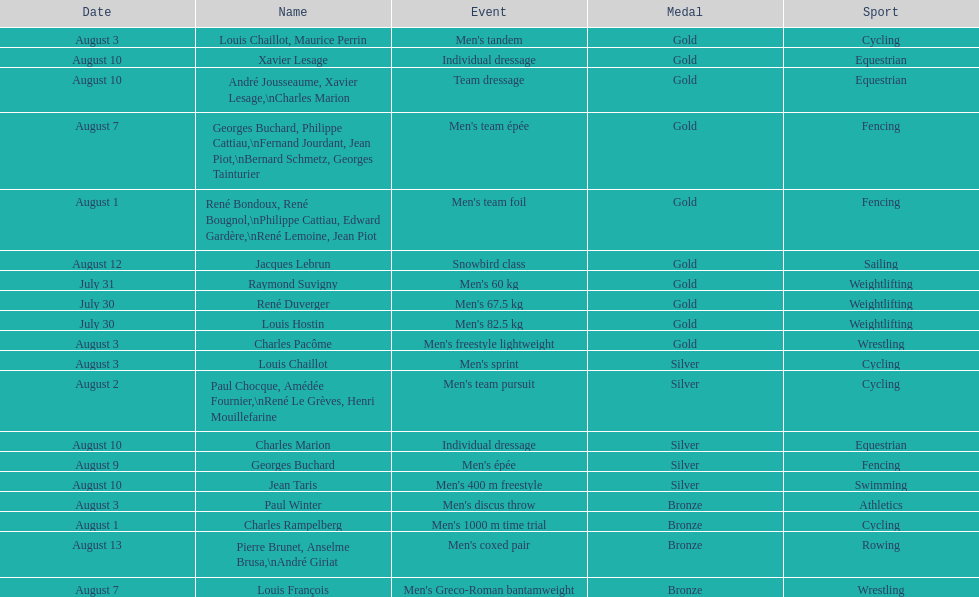How many total gold medals were won by weightlifting? 3. 